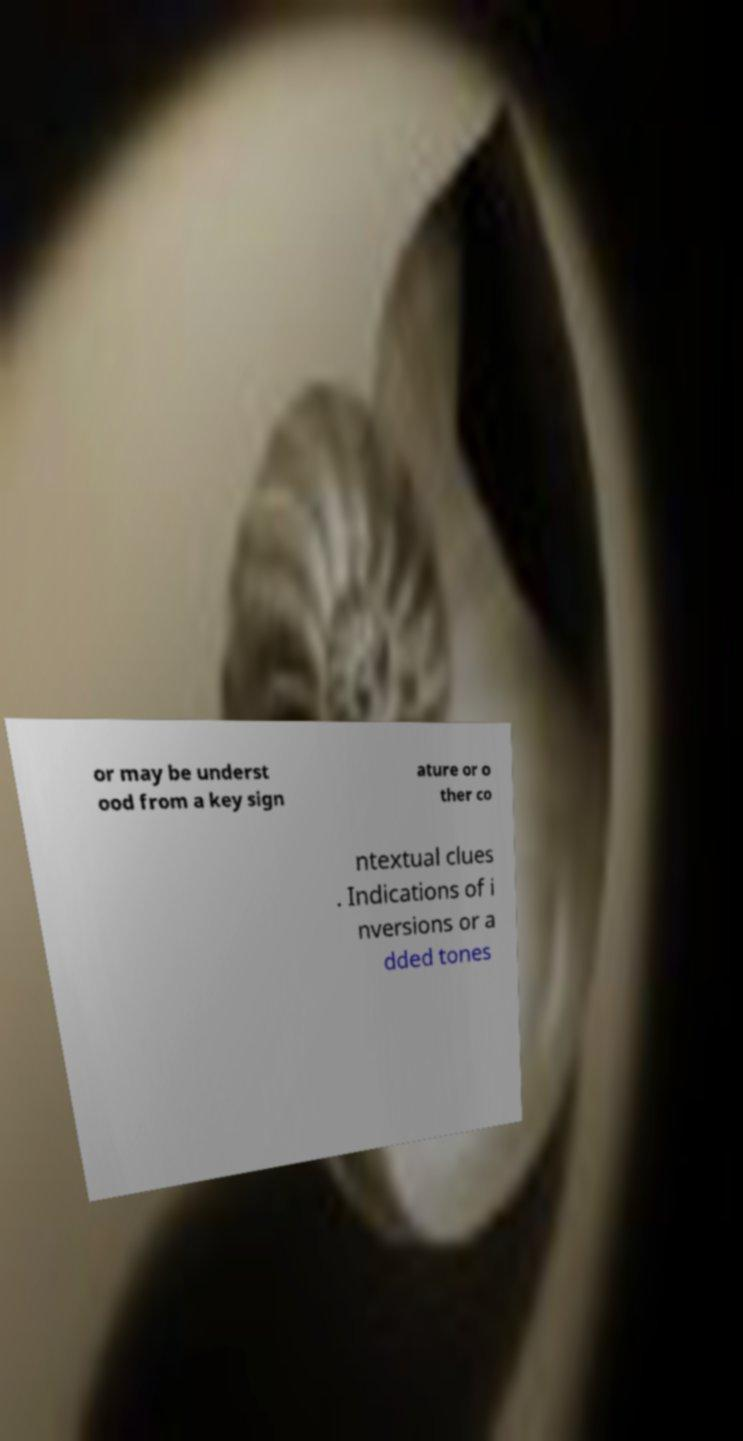Could you extract and type out the text from this image? or may be underst ood from a key sign ature or o ther co ntextual clues . Indications of i nversions or a dded tones 